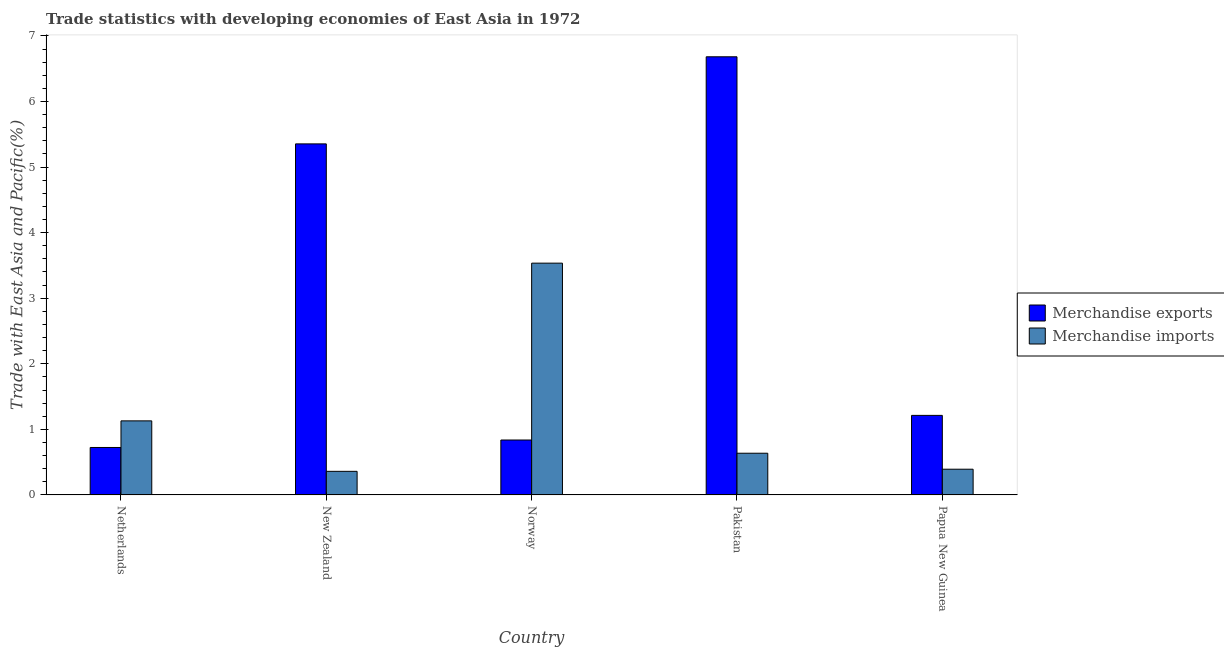Are the number of bars on each tick of the X-axis equal?
Offer a very short reply. Yes. How many bars are there on the 3rd tick from the right?
Offer a terse response. 2. What is the label of the 2nd group of bars from the left?
Make the answer very short. New Zealand. What is the merchandise exports in Papua New Guinea?
Provide a succinct answer. 1.21. Across all countries, what is the maximum merchandise exports?
Offer a very short reply. 6.68. Across all countries, what is the minimum merchandise imports?
Keep it short and to the point. 0.36. In which country was the merchandise exports minimum?
Offer a very short reply. Netherlands. What is the total merchandise imports in the graph?
Offer a very short reply. 6.05. What is the difference between the merchandise imports in New Zealand and that in Norway?
Your answer should be compact. -3.17. What is the difference between the merchandise imports in Netherlands and the merchandise exports in Papua New Guinea?
Your response must be concise. -0.08. What is the average merchandise imports per country?
Provide a succinct answer. 1.21. What is the difference between the merchandise exports and merchandise imports in Norway?
Your answer should be very brief. -2.7. What is the ratio of the merchandise imports in Norway to that in Papua New Guinea?
Ensure brevity in your answer.  9.01. Is the merchandise exports in Netherlands less than that in New Zealand?
Keep it short and to the point. Yes. What is the difference between the highest and the second highest merchandise imports?
Ensure brevity in your answer.  2.41. What is the difference between the highest and the lowest merchandise exports?
Ensure brevity in your answer.  5.96. What does the 1st bar from the right in Pakistan represents?
Your response must be concise. Merchandise imports. How many countries are there in the graph?
Keep it short and to the point. 5. Does the graph contain any zero values?
Your response must be concise. No. Does the graph contain grids?
Your answer should be compact. No. How are the legend labels stacked?
Your response must be concise. Vertical. What is the title of the graph?
Make the answer very short. Trade statistics with developing economies of East Asia in 1972. What is the label or title of the Y-axis?
Your answer should be very brief. Trade with East Asia and Pacific(%). What is the Trade with East Asia and Pacific(%) in Merchandise exports in Netherlands?
Make the answer very short. 0.72. What is the Trade with East Asia and Pacific(%) of Merchandise imports in Netherlands?
Your response must be concise. 1.13. What is the Trade with East Asia and Pacific(%) of Merchandise exports in New Zealand?
Your answer should be very brief. 5.35. What is the Trade with East Asia and Pacific(%) of Merchandise imports in New Zealand?
Your answer should be very brief. 0.36. What is the Trade with East Asia and Pacific(%) of Merchandise exports in Norway?
Your answer should be very brief. 0.84. What is the Trade with East Asia and Pacific(%) of Merchandise imports in Norway?
Your answer should be compact. 3.53. What is the Trade with East Asia and Pacific(%) of Merchandise exports in Pakistan?
Provide a succinct answer. 6.68. What is the Trade with East Asia and Pacific(%) of Merchandise imports in Pakistan?
Provide a short and direct response. 0.64. What is the Trade with East Asia and Pacific(%) of Merchandise exports in Papua New Guinea?
Provide a succinct answer. 1.21. What is the Trade with East Asia and Pacific(%) in Merchandise imports in Papua New Guinea?
Ensure brevity in your answer.  0.39. Across all countries, what is the maximum Trade with East Asia and Pacific(%) in Merchandise exports?
Make the answer very short. 6.68. Across all countries, what is the maximum Trade with East Asia and Pacific(%) of Merchandise imports?
Offer a terse response. 3.53. Across all countries, what is the minimum Trade with East Asia and Pacific(%) of Merchandise exports?
Provide a short and direct response. 0.72. Across all countries, what is the minimum Trade with East Asia and Pacific(%) in Merchandise imports?
Give a very brief answer. 0.36. What is the total Trade with East Asia and Pacific(%) in Merchandise exports in the graph?
Provide a short and direct response. 14.81. What is the total Trade with East Asia and Pacific(%) in Merchandise imports in the graph?
Ensure brevity in your answer.  6.05. What is the difference between the Trade with East Asia and Pacific(%) of Merchandise exports in Netherlands and that in New Zealand?
Make the answer very short. -4.63. What is the difference between the Trade with East Asia and Pacific(%) of Merchandise imports in Netherlands and that in New Zealand?
Give a very brief answer. 0.77. What is the difference between the Trade with East Asia and Pacific(%) in Merchandise exports in Netherlands and that in Norway?
Your response must be concise. -0.11. What is the difference between the Trade with East Asia and Pacific(%) in Merchandise imports in Netherlands and that in Norway?
Provide a short and direct response. -2.41. What is the difference between the Trade with East Asia and Pacific(%) in Merchandise exports in Netherlands and that in Pakistan?
Make the answer very short. -5.96. What is the difference between the Trade with East Asia and Pacific(%) of Merchandise imports in Netherlands and that in Pakistan?
Give a very brief answer. 0.49. What is the difference between the Trade with East Asia and Pacific(%) of Merchandise exports in Netherlands and that in Papua New Guinea?
Offer a very short reply. -0.49. What is the difference between the Trade with East Asia and Pacific(%) of Merchandise imports in Netherlands and that in Papua New Guinea?
Offer a very short reply. 0.74. What is the difference between the Trade with East Asia and Pacific(%) in Merchandise exports in New Zealand and that in Norway?
Your answer should be compact. 4.52. What is the difference between the Trade with East Asia and Pacific(%) in Merchandise imports in New Zealand and that in Norway?
Keep it short and to the point. -3.17. What is the difference between the Trade with East Asia and Pacific(%) of Merchandise exports in New Zealand and that in Pakistan?
Offer a terse response. -1.33. What is the difference between the Trade with East Asia and Pacific(%) in Merchandise imports in New Zealand and that in Pakistan?
Provide a succinct answer. -0.28. What is the difference between the Trade with East Asia and Pacific(%) in Merchandise exports in New Zealand and that in Papua New Guinea?
Your answer should be very brief. 4.14. What is the difference between the Trade with East Asia and Pacific(%) in Merchandise imports in New Zealand and that in Papua New Guinea?
Your answer should be compact. -0.03. What is the difference between the Trade with East Asia and Pacific(%) of Merchandise exports in Norway and that in Pakistan?
Offer a very short reply. -5.84. What is the difference between the Trade with East Asia and Pacific(%) in Merchandise imports in Norway and that in Pakistan?
Provide a succinct answer. 2.9. What is the difference between the Trade with East Asia and Pacific(%) of Merchandise exports in Norway and that in Papua New Guinea?
Give a very brief answer. -0.38. What is the difference between the Trade with East Asia and Pacific(%) in Merchandise imports in Norway and that in Papua New Guinea?
Keep it short and to the point. 3.14. What is the difference between the Trade with East Asia and Pacific(%) in Merchandise exports in Pakistan and that in Papua New Guinea?
Make the answer very short. 5.47. What is the difference between the Trade with East Asia and Pacific(%) of Merchandise imports in Pakistan and that in Papua New Guinea?
Give a very brief answer. 0.24. What is the difference between the Trade with East Asia and Pacific(%) in Merchandise exports in Netherlands and the Trade with East Asia and Pacific(%) in Merchandise imports in New Zealand?
Provide a short and direct response. 0.36. What is the difference between the Trade with East Asia and Pacific(%) of Merchandise exports in Netherlands and the Trade with East Asia and Pacific(%) of Merchandise imports in Norway?
Your response must be concise. -2.81. What is the difference between the Trade with East Asia and Pacific(%) of Merchandise exports in Netherlands and the Trade with East Asia and Pacific(%) of Merchandise imports in Pakistan?
Ensure brevity in your answer.  0.09. What is the difference between the Trade with East Asia and Pacific(%) of Merchandise exports in Netherlands and the Trade with East Asia and Pacific(%) of Merchandise imports in Papua New Guinea?
Your answer should be very brief. 0.33. What is the difference between the Trade with East Asia and Pacific(%) in Merchandise exports in New Zealand and the Trade with East Asia and Pacific(%) in Merchandise imports in Norway?
Your response must be concise. 1.82. What is the difference between the Trade with East Asia and Pacific(%) in Merchandise exports in New Zealand and the Trade with East Asia and Pacific(%) in Merchandise imports in Pakistan?
Provide a succinct answer. 4.72. What is the difference between the Trade with East Asia and Pacific(%) of Merchandise exports in New Zealand and the Trade with East Asia and Pacific(%) of Merchandise imports in Papua New Guinea?
Give a very brief answer. 4.96. What is the difference between the Trade with East Asia and Pacific(%) of Merchandise exports in Norway and the Trade with East Asia and Pacific(%) of Merchandise imports in Pakistan?
Your answer should be very brief. 0.2. What is the difference between the Trade with East Asia and Pacific(%) in Merchandise exports in Norway and the Trade with East Asia and Pacific(%) in Merchandise imports in Papua New Guinea?
Your answer should be compact. 0.45. What is the difference between the Trade with East Asia and Pacific(%) of Merchandise exports in Pakistan and the Trade with East Asia and Pacific(%) of Merchandise imports in Papua New Guinea?
Your answer should be compact. 6.29. What is the average Trade with East Asia and Pacific(%) in Merchandise exports per country?
Provide a succinct answer. 2.96. What is the average Trade with East Asia and Pacific(%) of Merchandise imports per country?
Make the answer very short. 1.21. What is the difference between the Trade with East Asia and Pacific(%) of Merchandise exports and Trade with East Asia and Pacific(%) of Merchandise imports in Netherlands?
Offer a very short reply. -0.41. What is the difference between the Trade with East Asia and Pacific(%) in Merchandise exports and Trade with East Asia and Pacific(%) in Merchandise imports in New Zealand?
Your answer should be compact. 4.99. What is the difference between the Trade with East Asia and Pacific(%) of Merchandise exports and Trade with East Asia and Pacific(%) of Merchandise imports in Norway?
Provide a succinct answer. -2.7. What is the difference between the Trade with East Asia and Pacific(%) in Merchandise exports and Trade with East Asia and Pacific(%) in Merchandise imports in Pakistan?
Offer a terse response. 6.05. What is the difference between the Trade with East Asia and Pacific(%) of Merchandise exports and Trade with East Asia and Pacific(%) of Merchandise imports in Papua New Guinea?
Ensure brevity in your answer.  0.82. What is the ratio of the Trade with East Asia and Pacific(%) in Merchandise exports in Netherlands to that in New Zealand?
Offer a very short reply. 0.14. What is the ratio of the Trade with East Asia and Pacific(%) in Merchandise imports in Netherlands to that in New Zealand?
Offer a terse response. 3.14. What is the ratio of the Trade with East Asia and Pacific(%) in Merchandise exports in Netherlands to that in Norway?
Provide a succinct answer. 0.86. What is the ratio of the Trade with East Asia and Pacific(%) in Merchandise imports in Netherlands to that in Norway?
Give a very brief answer. 0.32. What is the ratio of the Trade with East Asia and Pacific(%) of Merchandise exports in Netherlands to that in Pakistan?
Give a very brief answer. 0.11. What is the ratio of the Trade with East Asia and Pacific(%) in Merchandise imports in Netherlands to that in Pakistan?
Give a very brief answer. 1.78. What is the ratio of the Trade with East Asia and Pacific(%) in Merchandise exports in Netherlands to that in Papua New Guinea?
Your answer should be compact. 0.6. What is the ratio of the Trade with East Asia and Pacific(%) in Merchandise imports in Netherlands to that in Papua New Guinea?
Ensure brevity in your answer.  2.88. What is the ratio of the Trade with East Asia and Pacific(%) in Merchandise exports in New Zealand to that in Norway?
Ensure brevity in your answer.  6.39. What is the ratio of the Trade with East Asia and Pacific(%) in Merchandise imports in New Zealand to that in Norway?
Your answer should be very brief. 0.1. What is the ratio of the Trade with East Asia and Pacific(%) in Merchandise exports in New Zealand to that in Pakistan?
Make the answer very short. 0.8. What is the ratio of the Trade with East Asia and Pacific(%) in Merchandise imports in New Zealand to that in Pakistan?
Your answer should be very brief. 0.57. What is the ratio of the Trade with East Asia and Pacific(%) of Merchandise exports in New Zealand to that in Papua New Guinea?
Give a very brief answer. 4.41. What is the ratio of the Trade with East Asia and Pacific(%) of Merchandise imports in New Zealand to that in Papua New Guinea?
Make the answer very short. 0.92. What is the ratio of the Trade with East Asia and Pacific(%) of Merchandise exports in Norway to that in Pakistan?
Your response must be concise. 0.13. What is the ratio of the Trade with East Asia and Pacific(%) in Merchandise imports in Norway to that in Pakistan?
Provide a succinct answer. 5.56. What is the ratio of the Trade with East Asia and Pacific(%) of Merchandise exports in Norway to that in Papua New Guinea?
Provide a succinct answer. 0.69. What is the ratio of the Trade with East Asia and Pacific(%) of Merchandise imports in Norway to that in Papua New Guinea?
Make the answer very short. 9.01. What is the ratio of the Trade with East Asia and Pacific(%) of Merchandise exports in Pakistan to that in Papua New Guinea?
Provide a succinct answer. 5.51. What is the ratio of the Trade with East Asia and Pacific(%) in Merchandise imports in Pakistan to that in Papua New Guinea?
Ensure brevity in your answer.  1.62. What is the difference between the highest and the second highest Trade with East Asia and Pacific(%) in Merchandise exports?
Ensure brevity in your answer.  1.33. What is the difference between the highest and the second highest Trade with East Asia and Pacific(%) of Merchandise imports?
Offer a terse response. 2.41. What is the difference between the highest and the lowest Trade with East Asia and Pacific(%) of Merchandise exports?
Provide a succinct answer. 5.96. What is the difference between the highest and the lowest Trade with East Asia and Pacific(%) of Merchandise imports?
Offer a very short reply. 3.17. 